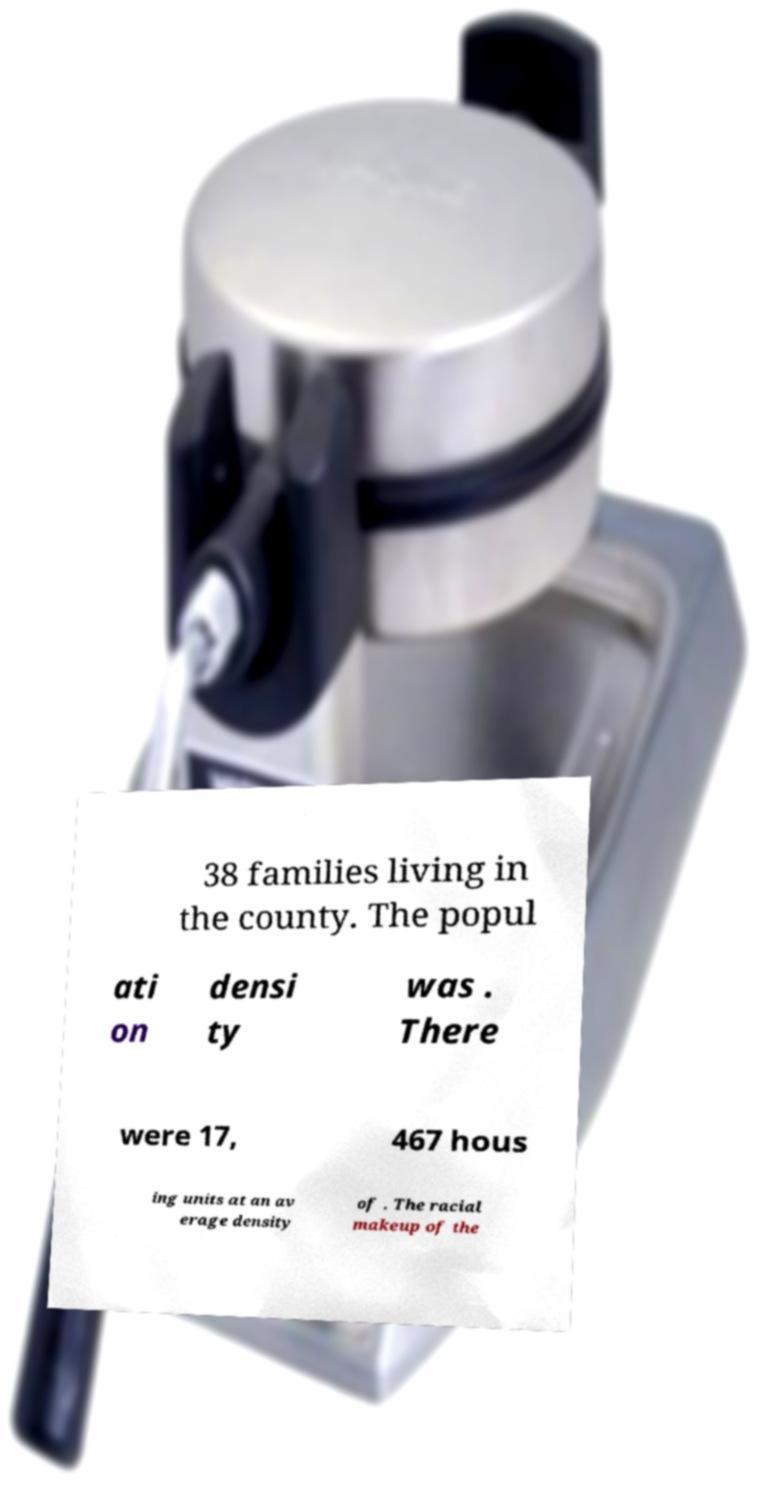Can you read and provide the text displayed in the image?This photo seems to have some interesting text. Can you extract and type it out for me? 38 families living in the county. The popul ati on densi ty was . There were 17, 467 hous ing units at an av erage density of . The racial makeup of the 